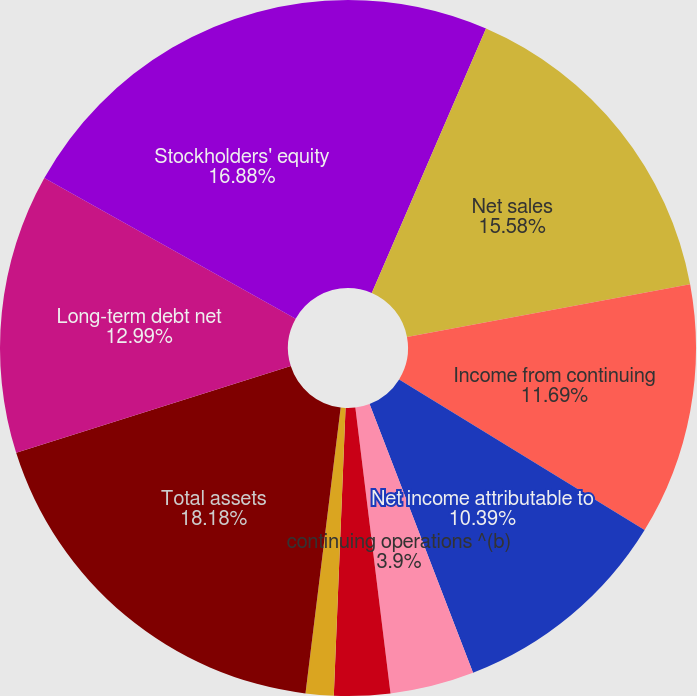Convert chart to OTSL. <chart><loc_0><loc_0><loc_500><loc_500><pie_chart><fcel>As of and for the years ended<fcel>Net sales<fcel>Income from continuing<fcel>Net income attributable to<fcel>continuing operations ^(b)<fcel>Basic earnings per common<fcel>Diluted earnings per common<fcel>Total assets<fcel>Long-term debt net<fcel>Stockholders' equity<nl><fcel>6.49%<fcel>15.58%<fcel>11.69%<fcel>10.39%<fcel>3.9%<fcel>2.6%<fcel>1.3%<fcel>18.18%<fcel>12.99%<fcel>16.88%<nl></chart> 